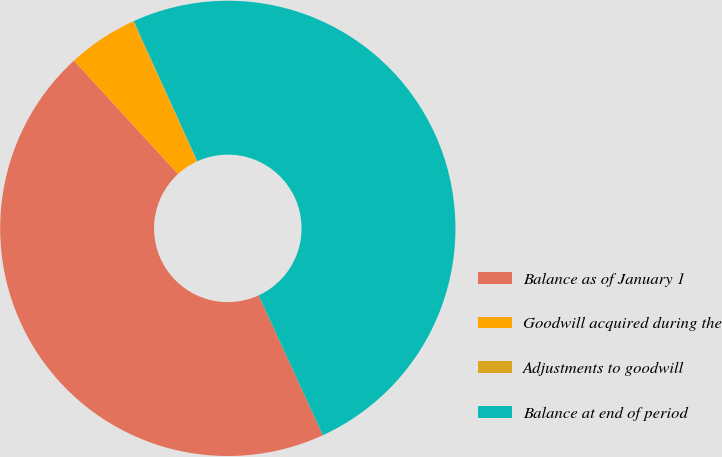Convert chart to OTSL. <chart><loc_0><loc_0><loc_500><loc_500><pie_chart><fcel>Balance as of January 1<fcel>Goodwill acquired during the<fcel>Adjustments to goodwill<fcel>Balance at end of period<nl><fcel>45.05%<fcel>4.95%<fcel>0.09%<fcel>49.91%<nl></chart> 